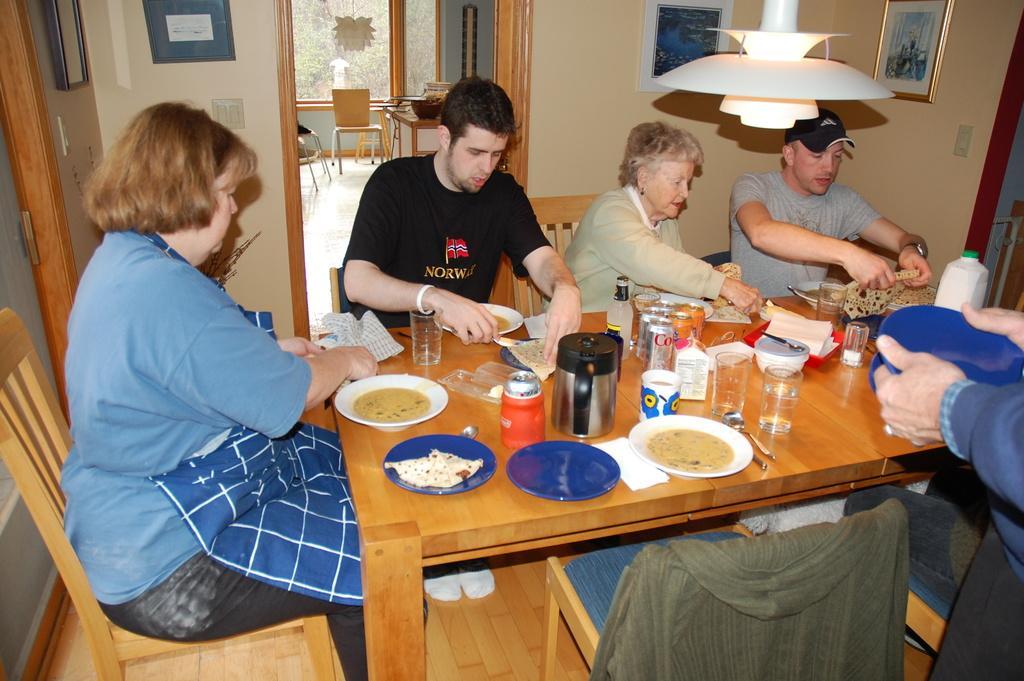How would you summarize this image in a sentence or two? On the background we can see trees through window glasses. Empty chairs and table. Here we can see photo frames over a wall. This is a light. Here we can see few persons sitting on chairs in front of a dining table and on the table we can see a plate of food, plates, tins, glasses and tissue papers. Here there is a jacket over a chair. Here we can see partial part of human holding a bowl. 